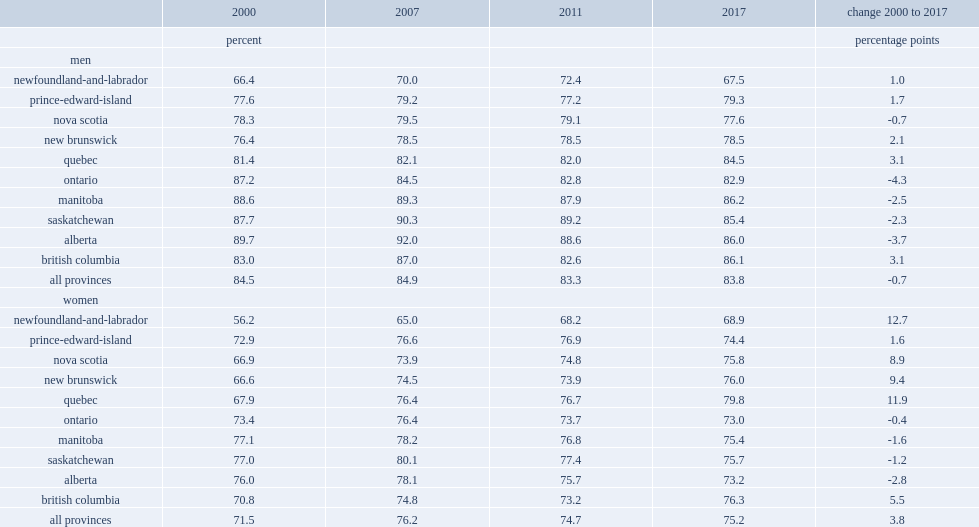How many percentage points did employment rates of canadian men aged 25 to 54 without a bachelor's degree fall from 2000 to 2017 nationwide? 0.7. In which places the employment rates of canadian men aged 25 to 54 without a bachelor's degree fell from 2000 to 2017? Ontario alberta. In which places the employment rates of canadian men aged 25 to 54 without a bachelor's degree rose slightly from 2000 to 2017? Newfoundland-and-labrador prince-edward-island new brunswick quebec british columbia. How many percentage points did employment rates of canadian women aged 25 to 54 without a bachelor's degree fall from 2000 to 2017 nationwide? 3.8. In which places the employment rates of canadian men aged 25 to 54 without a bachelor's degree rose rom 2000 to 2017? Quebec newfoundland-and-labrador. In which places the employment rates of canadian men aged 25 to 54 without a bachelor's degree showed no growth from 2000 to 2017? Quebec newfoundland-and-labrador. 